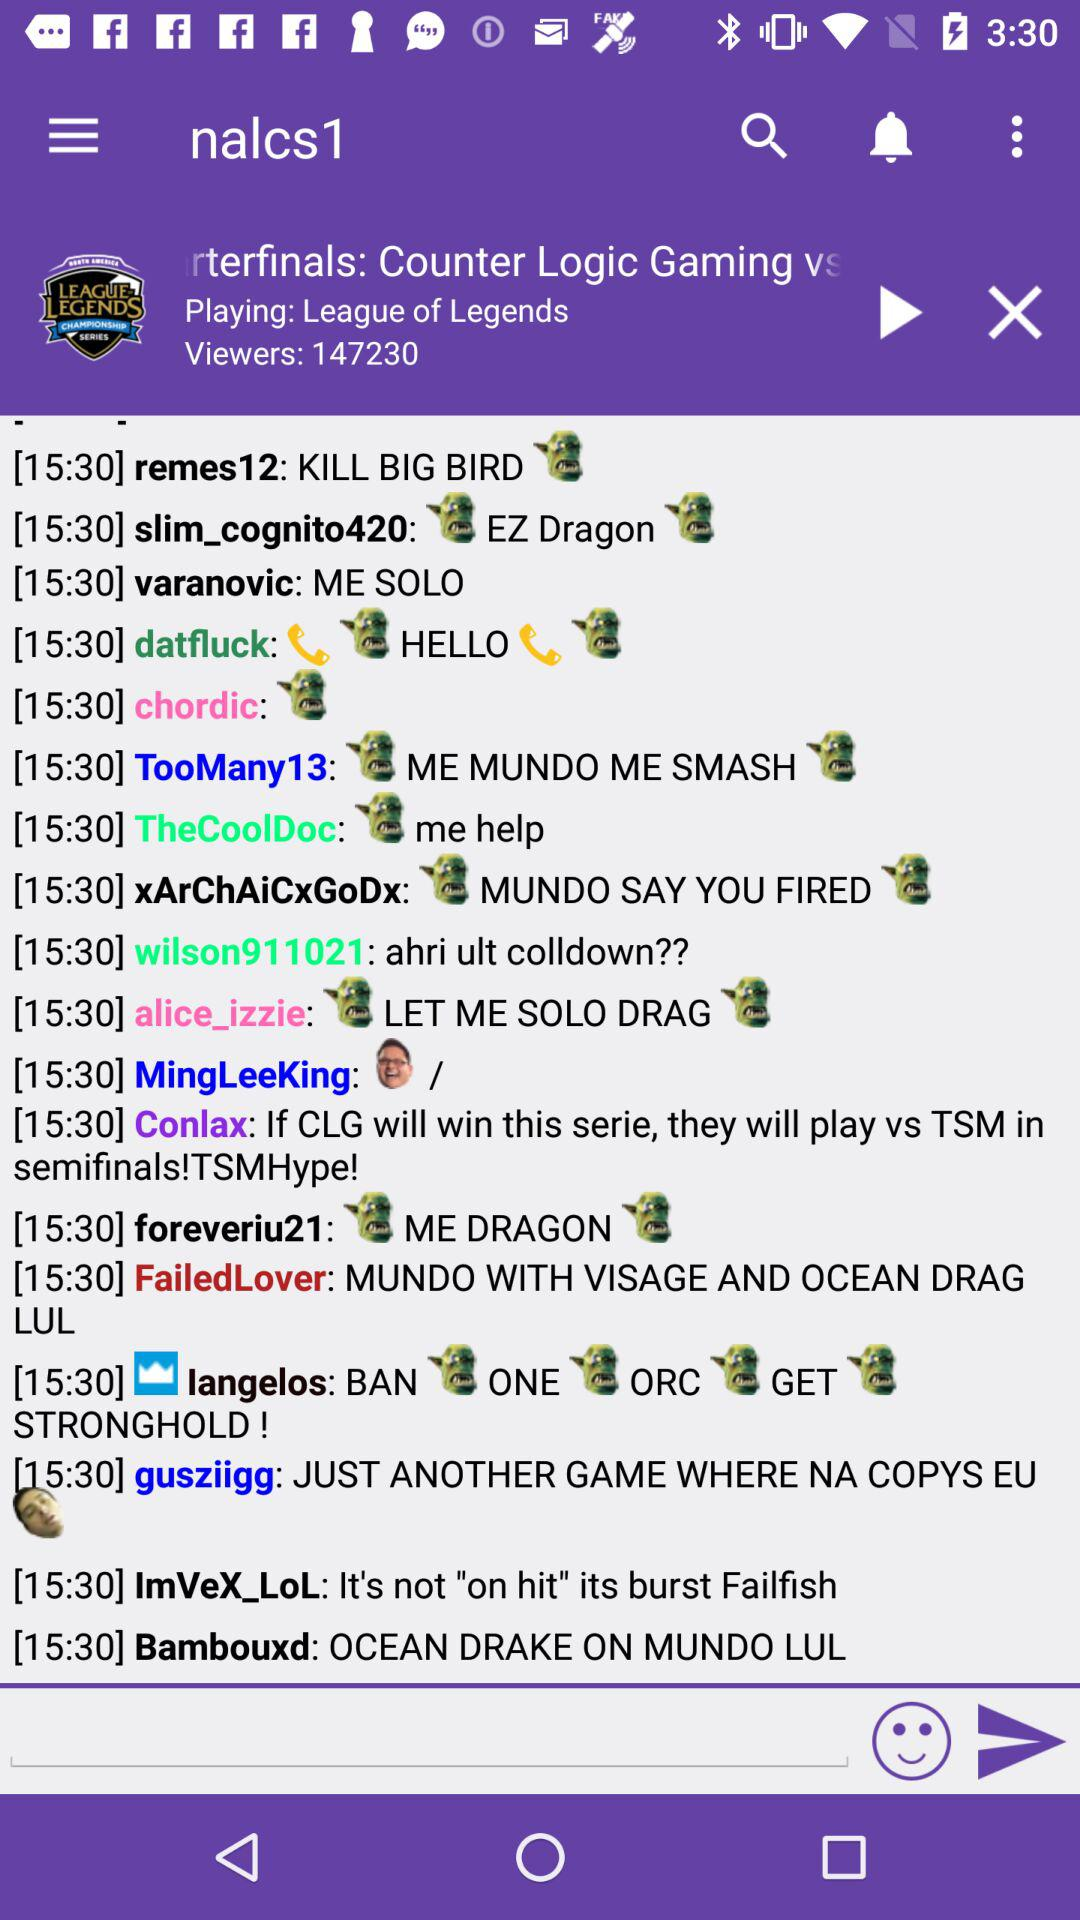What is the name of the album playing? The name of the album is "League of Legends". 